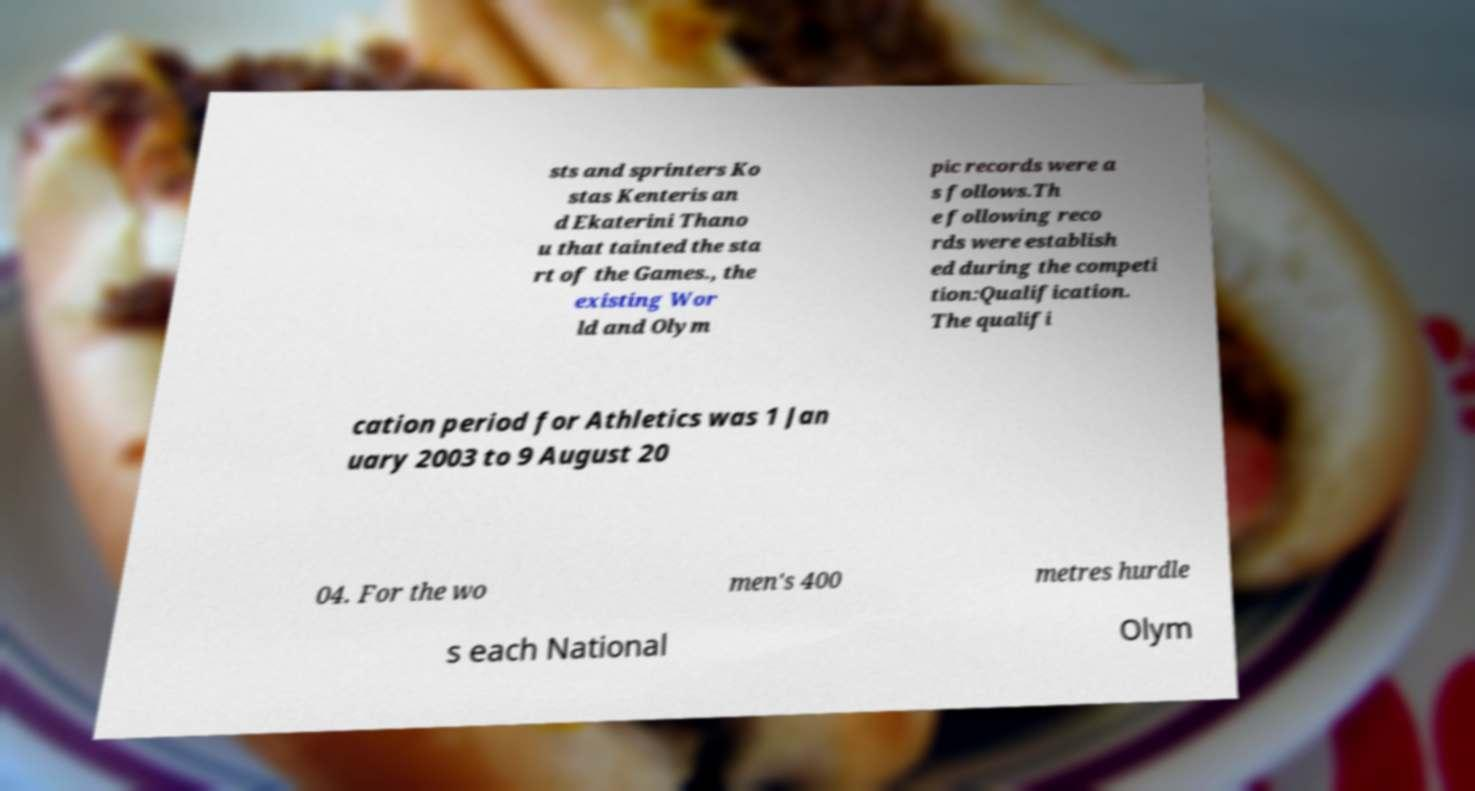Could you extract and type out the text from this image? sts and sprinters Ko stas Kenteris an d Ekaterini Thano u that tainted the sta rt of the Games., the existing Wor ld and Olym pic records were a s follows.Th e following reco rds were establish ed during the competi tion:Qualification. The qualifi cation period for Athletics was 1 Jan uary 2003 to 9 August 20 04. For the wo men's 400 metres hurdle s each National Olym 